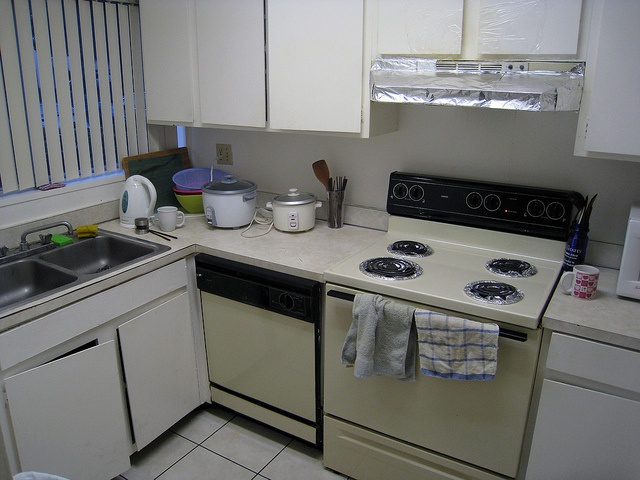Describe the objects in this image and their specific colors. I can see oven in gray, black, darkgray, and darkgreen tones, sink in gray, black, and darkgray tones, microwave in gray tones, cup in gray and purple tones, and bottle in gray, black, and navy tones in this image. 